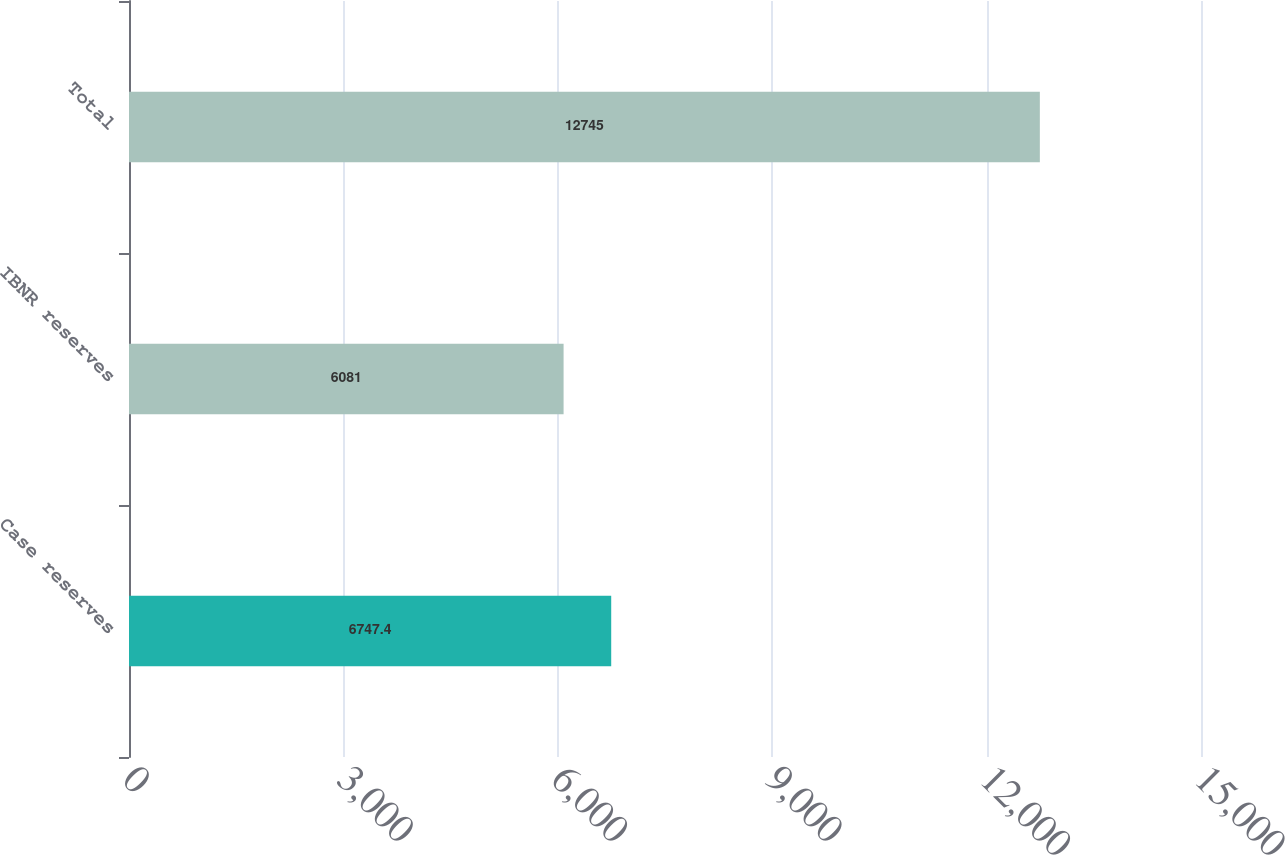Convert chart. <chart><loc_0><loc_0><loc_500><loc_500><bar_chart><fcel>Case reserves<fcel>IBNR reserves<fcel>Total<nl><fcel>6747.4<fcel>6081<fcel>12745<nl></chart> 